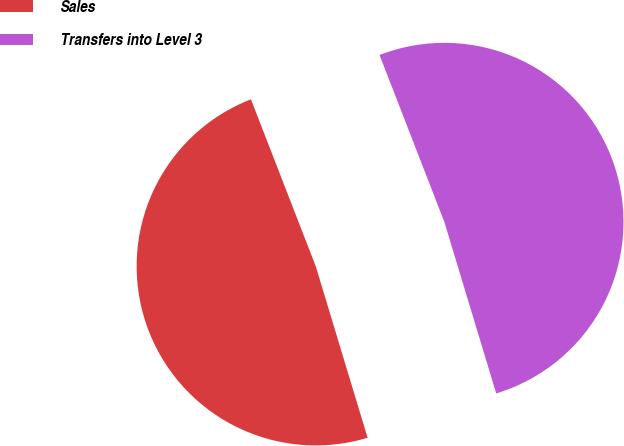Convert chart to OTSL. <chart><loc_0><loc_0><loc_500><loc_500><pie_chart><fcel>Sales<fcel>Transfers into Level 3<nl><fcel>48.78%<fcel>51.22%<nl></chart> 